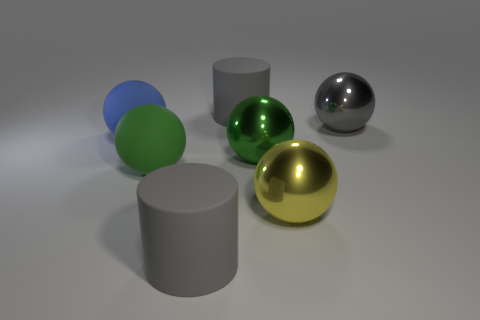The green thing that is made of the same material as the blue ball is what shape?
Provide a succinct answer. Sphere. What size is the gray thing that is in front of the green matte ball?
Make the answer very short. Large. Are there the same number of yellow metal objects behind the large green rubber thing and green shiny objects in front of the gray metallic object?
Offer a terse response. No. There is a big matte cylinder that is in front of the thing behind the gray sphere that is on the right side of the large green metal thing; what is its color?
Your answer should be compact. Gray. What number of spheres are on the left side of the large yellow shiny thing and on the right side of the big blue rubber ball?
Offer a terse response. 2. There is a object that is to the right of the large yellow metallic thing; is it the same color as the object in front of the large yellow metallic sphere?
Provide a succinct answer. Yes. There is a big green matte sphere; are there any green spheres behind it?
Ensure brevity in your answer.  Yes. Is the number of yellow metallic spheres to the right of the big yellow metallic thing the same as the number of green metal spheres?
Make the answer very short. No. Are there any matte objects on the right side of the gray cylinder in front of the matte cylinder behind the gray metal thing?
Your answer should be very brief. Yes. What material is the large yellow ball?
Give a very brief answer. Metal. 